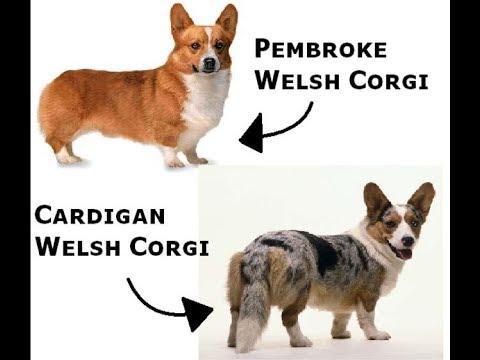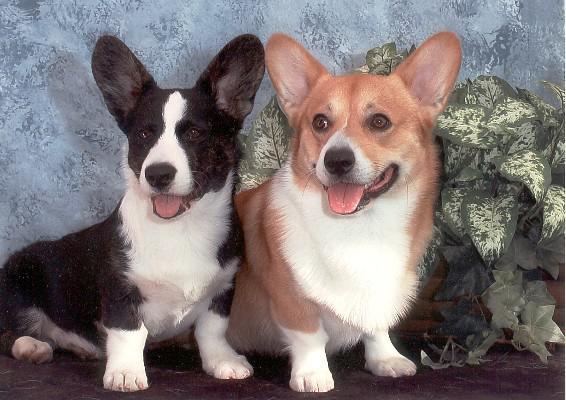The first image is the image on the left, the second image is the image on the right. Evaluate the accuracy of this statement regarding the images: "There are four dogs in the image pair.". Is it true? Answer yes or no. Yes. The first image is the image on the left, the second image is the image on the right. Assess this claim about the two images: "The left image contains exactly two dogs.". Correct or not? Answer yes or no. Yes. 